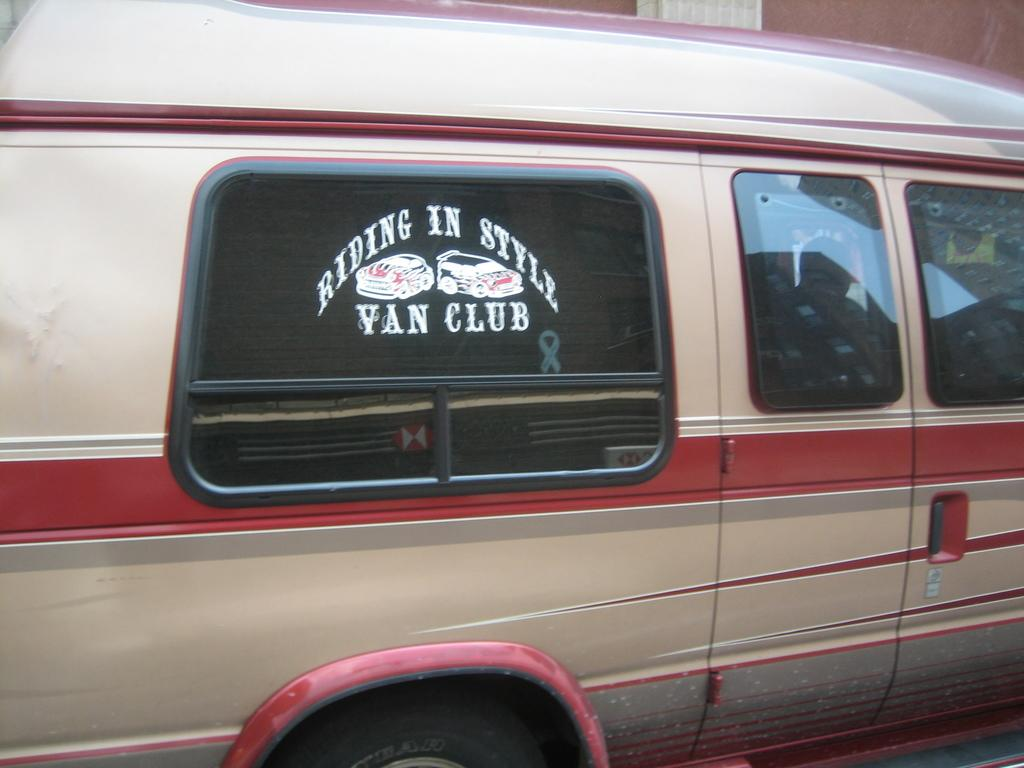<image>
Offer a succinct explanation of the picture presented. A sign in the window of a van says "Riding in Style Van Club". 